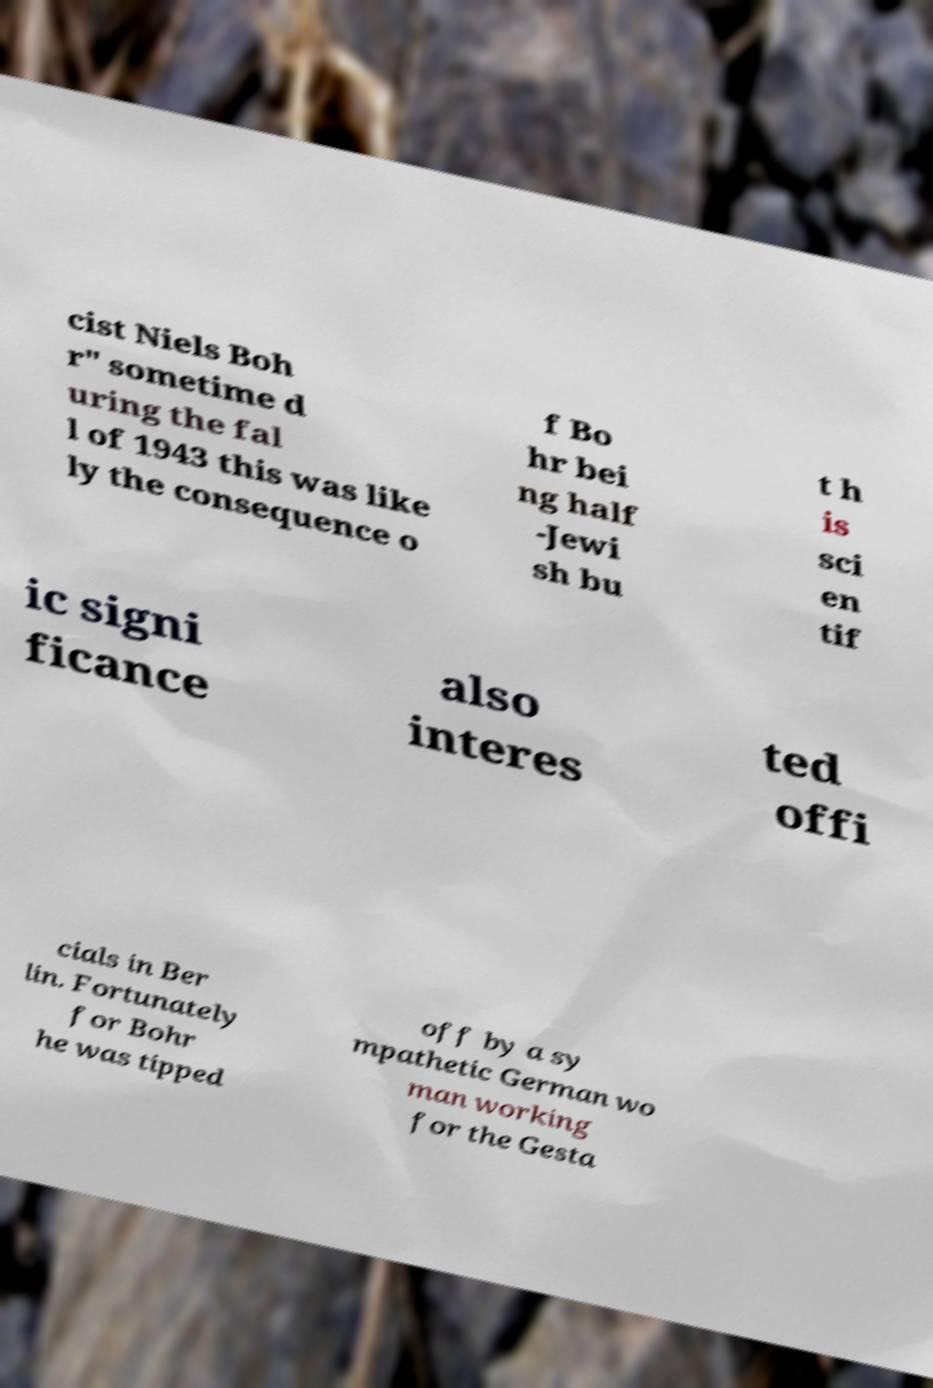Could you assist in decoding the text presented in this image and type it out clearly? cist Niels Boh r" sometime d uring the fal l of 1943 this was like ly the consequence o f Bo hr bei ng half -Jewi sh bu t h is sci en tif ic signi ficance also interes ted offi cials in Ber lin. Fortunately for Bohr he was tipped off by a sy mpathetic German wo man working for the Gesta 